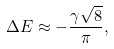Convert formula to latex. <formula><loc_0><loc_0><loc_500><loc_500>\Delta E \approx - \frac { { \gamma } \sqrt { 8 } } { \pi } ,</formula> 